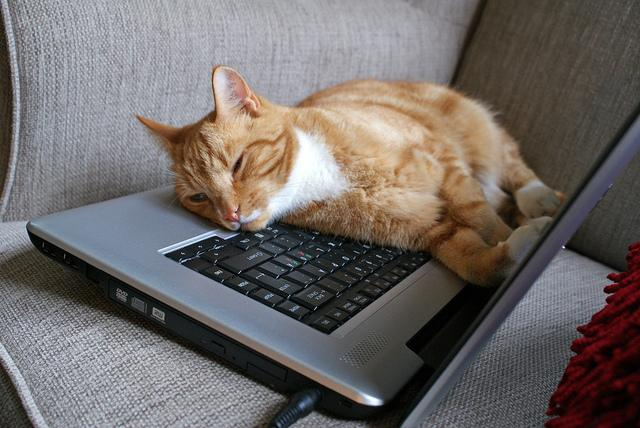Why is the cat likely sleeping on the laptop?

Choices:
A) attention
B) unknown
C) work
D) heat heat 